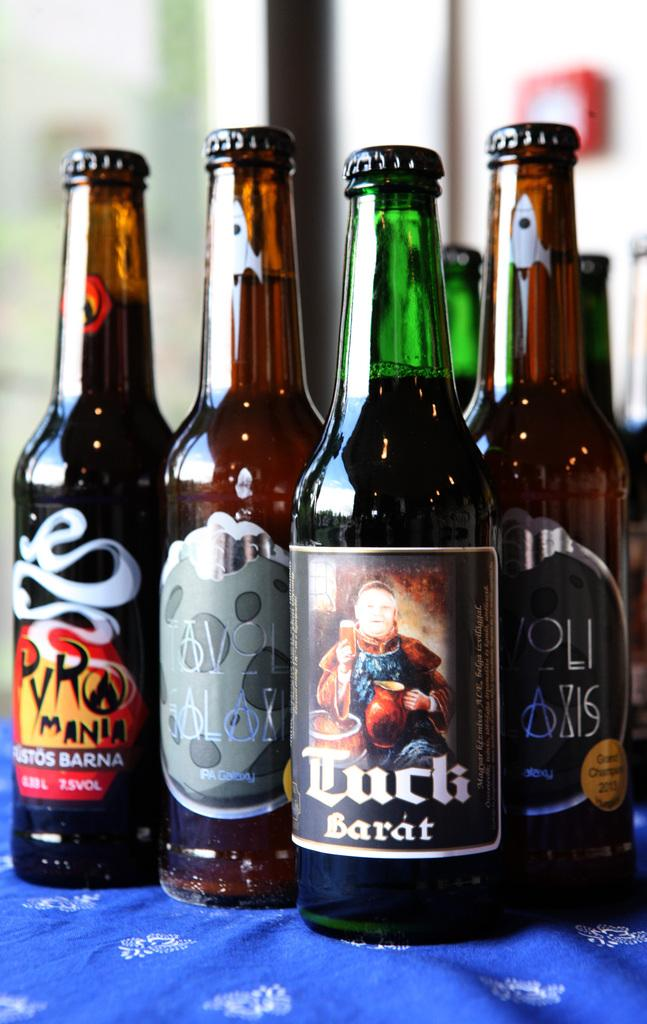What objects are present in the image? There are bottles in the image. Can you tell me how many credits are being given for the bottles in the image? There is no mention of credits or any reward system in the image; it only shows bottles. Is there a volcano erupting in the background of the image? There is no volcano or any indication of an eruption in the image; it only shows bottles. 